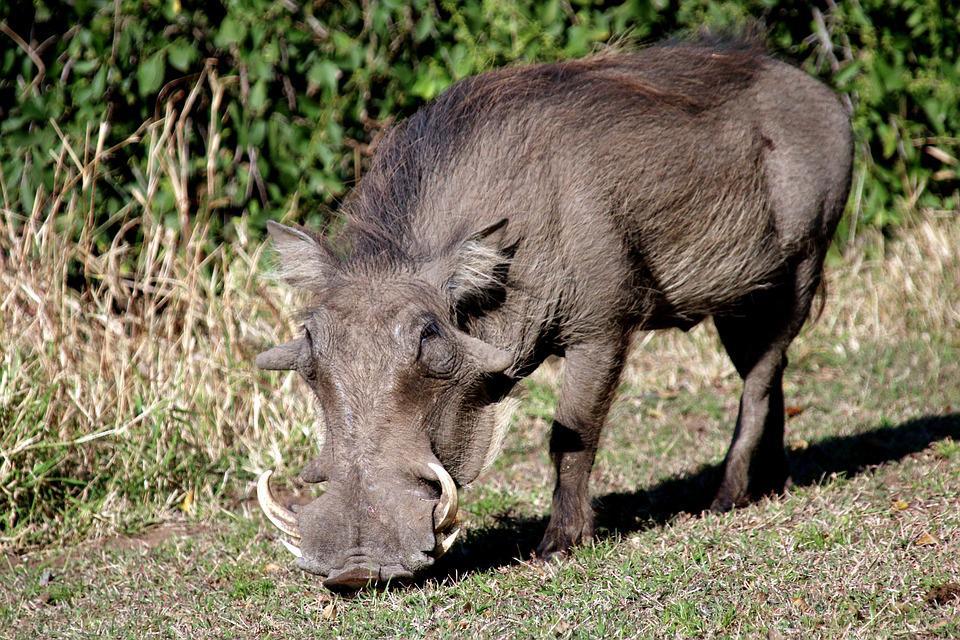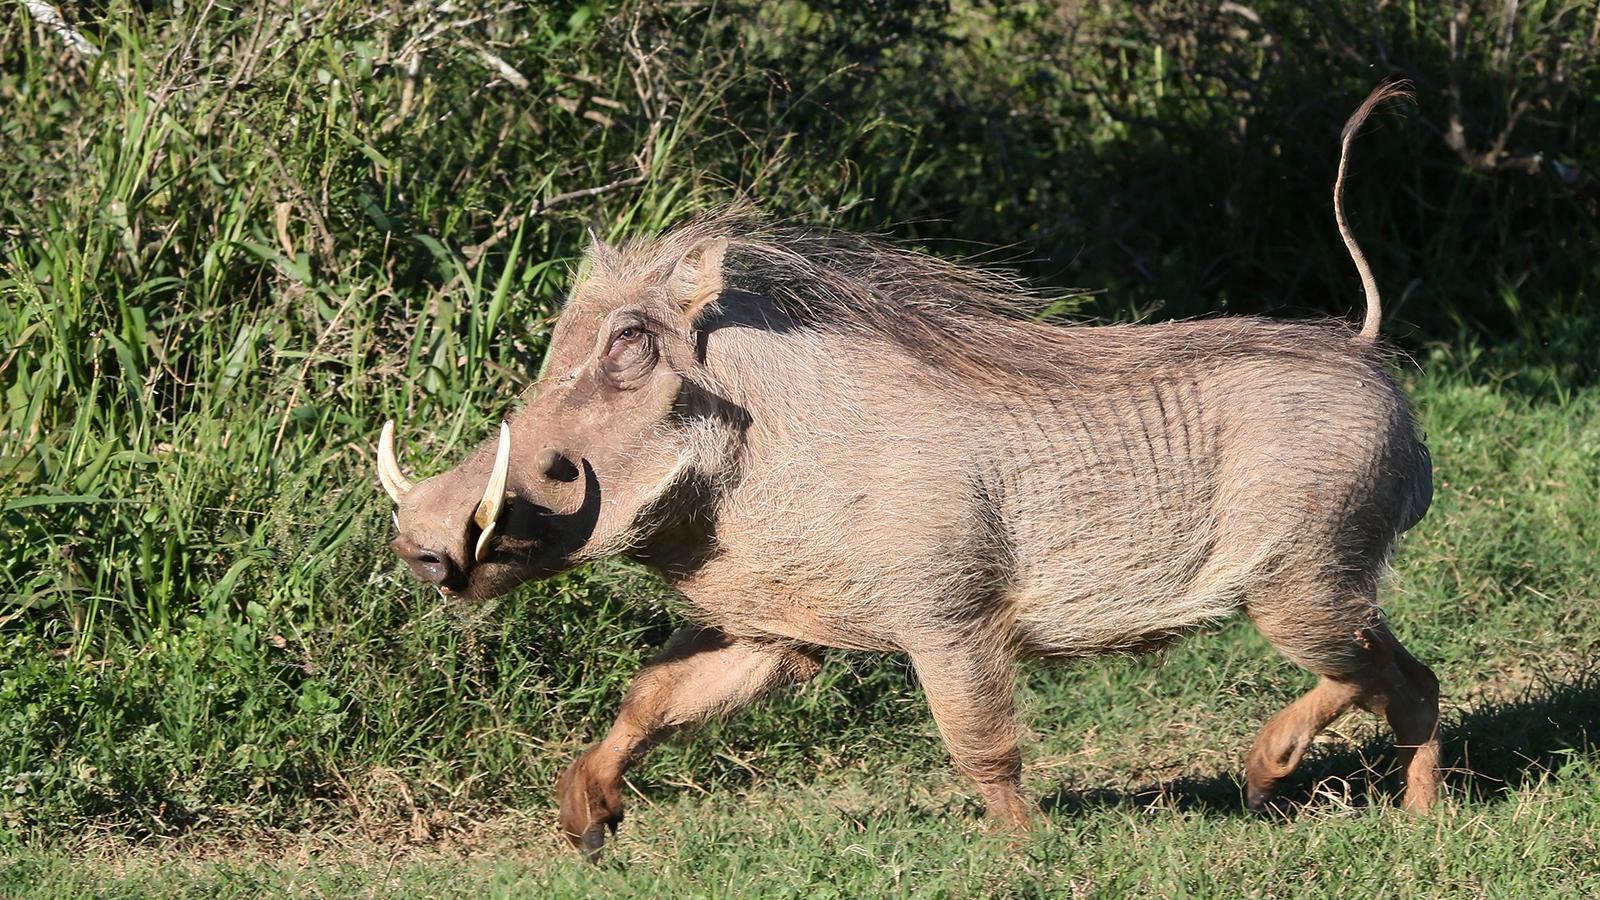The first image is the image on the left, the second image is the image on the right. Considering the images on both sides, is "A total of two animals are shown in a natural setting." valid? Answer yes or no. Yes. 